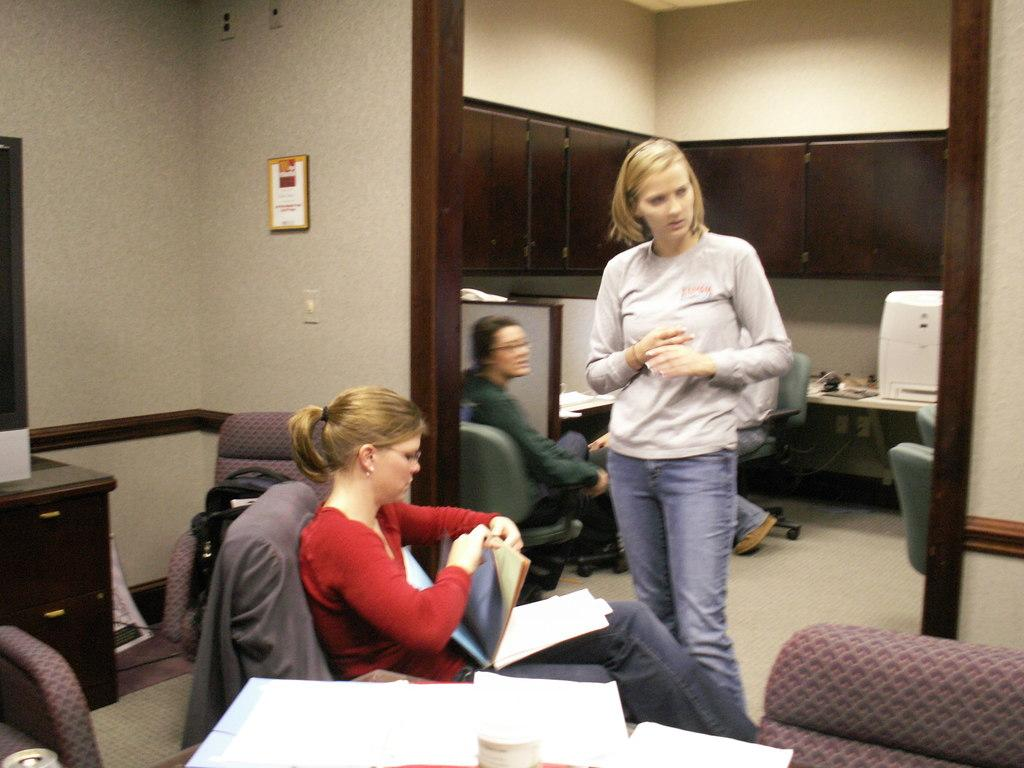What is the main subject in the middle of the image? There is a girl standing in the middle of the image. What is the girl wearing in the image? The girl is wearing a T-shirt and jeans. What can be seen on the left side of the image? There is a woman sitting on a sofa chair in the left side of the image. What is the woman wearing in the image? The woman is wearing a red color dress. What type of jam is being spread on the hot power lines in the image? There is no jam or power lines present in the image. 